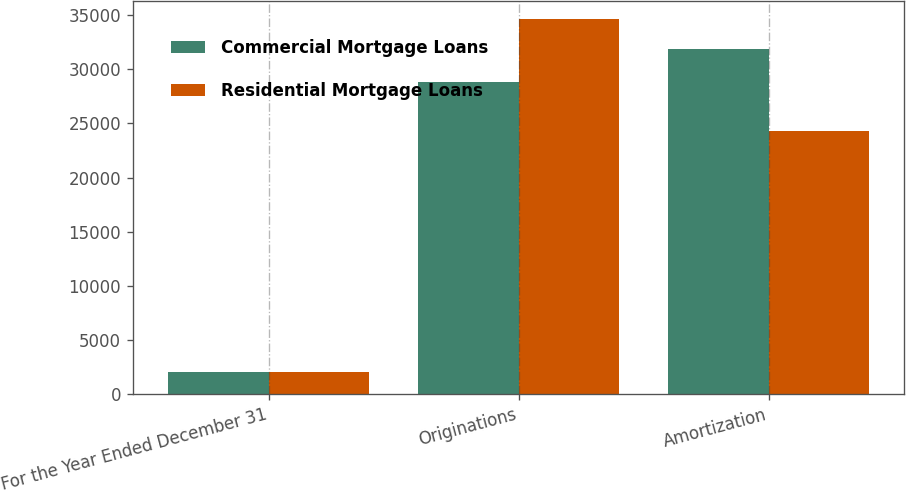<chart> <loc_0><loc_0><loc_500><loc_500><stacked_bar_chart><ecel><fcel>For the Year Ended December 31<fcel>Originations<fcel>Amortization<nl><fcel>Commercial Mortgage Loans<fcel>2017<fcel>28792<fcel>31864<nl><fcel>Residential Mortgage Loans<fcel>2017<fcel>34620<fcel>24308<nl></chart> 